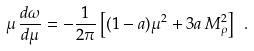<formula> <loc_0><loc_0><loc_500><loc_500>\mu \, \frac { d \omega } { d \mu } = - \frac { 1 } { 2 \pi } \left [ ( 1 - a ) \mu ^ { 2 } + 3 a \, M _ { \rho } ^ { 2 } \right ] \ .</formula> 